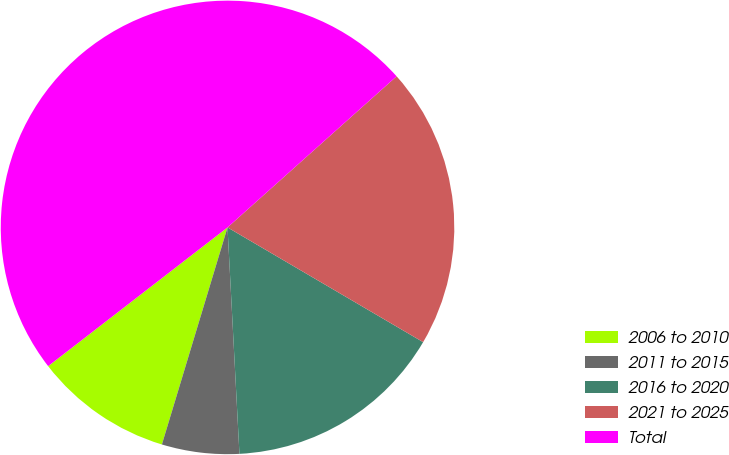<chart> <loc_0><loc_0><loc_500><loc_500><pie_chart><fcel>2006 to 2010<fcel>2011 to 2015<fcel>2016 to 2020<fcel>2021 to 2025<fcel>Total<nl><fcel>9.85%<fcel>5.51%<fcel>15.72%<fcel>20.05%<fcel>48.87%<nl></chart> 